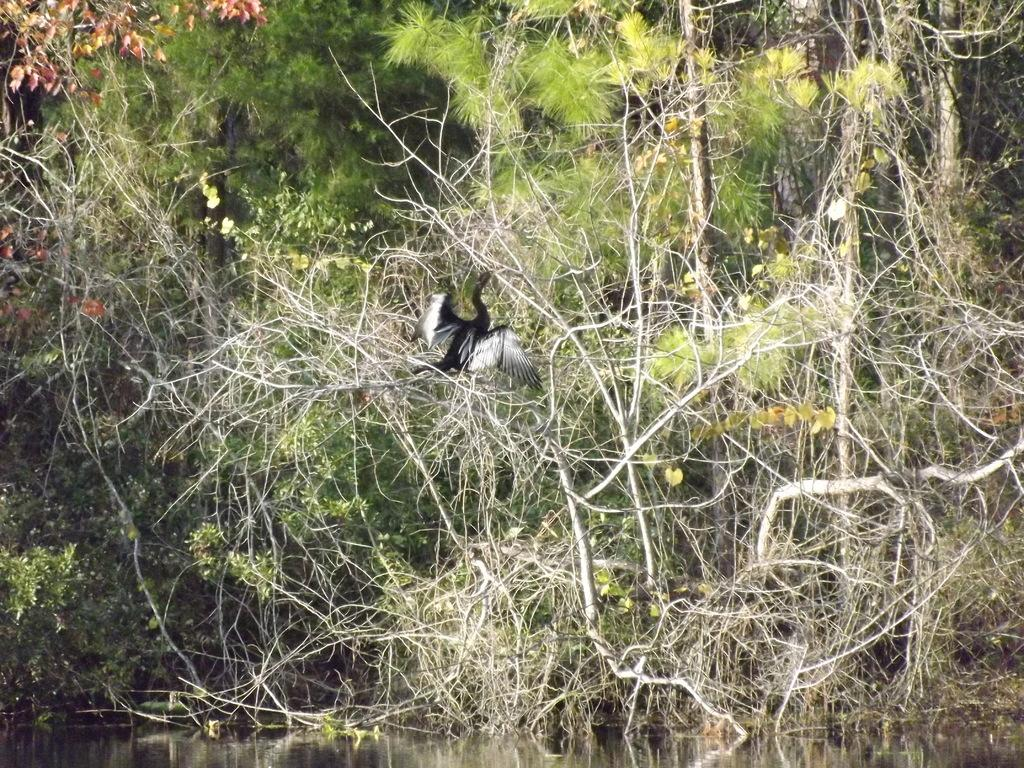What is visible at the bottom of the image? There is water visible at the bottom of the image. What can be seen on a plant in the image? There is a bird on a plant in the image. What type of vegetation is visible in the background of the image? There are trees and plants in the background of the image. What type of fan is visible in the image? There is no fan present in the image. How does the bird slip on the plant in the image? The bird does not slip on the plant in the image; it is perched on the plant. 